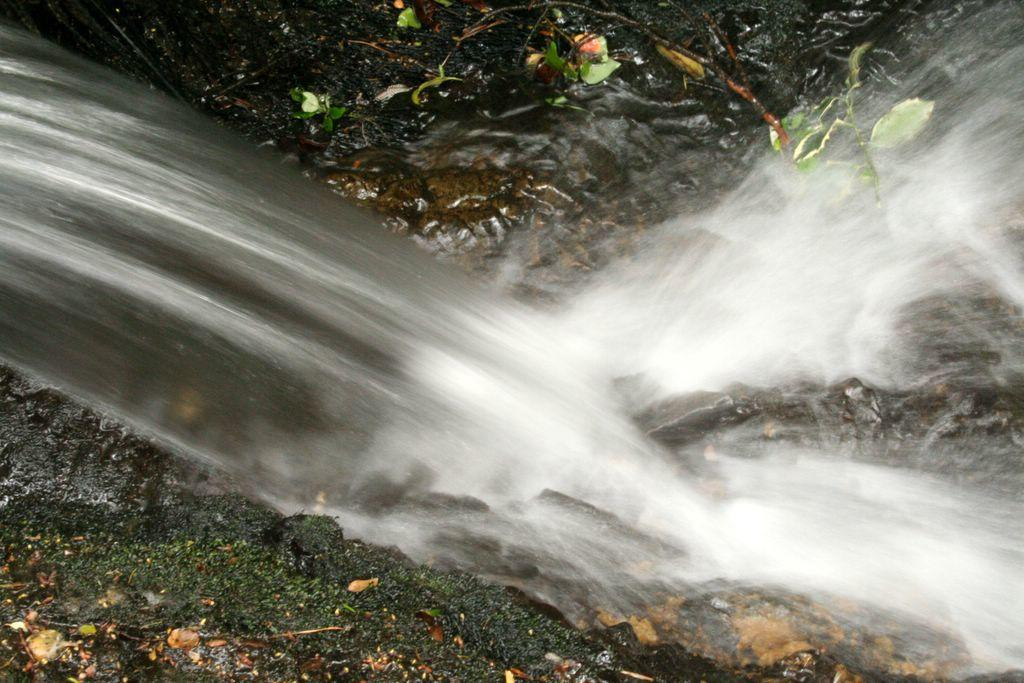What is visible in the image? Water is visible in the image. Where are the plants located in the image? The plants are in the right top corner of the image. What type of straw is used to stir the water in the image? There is no straw present in the image; it only shows water and plants. 